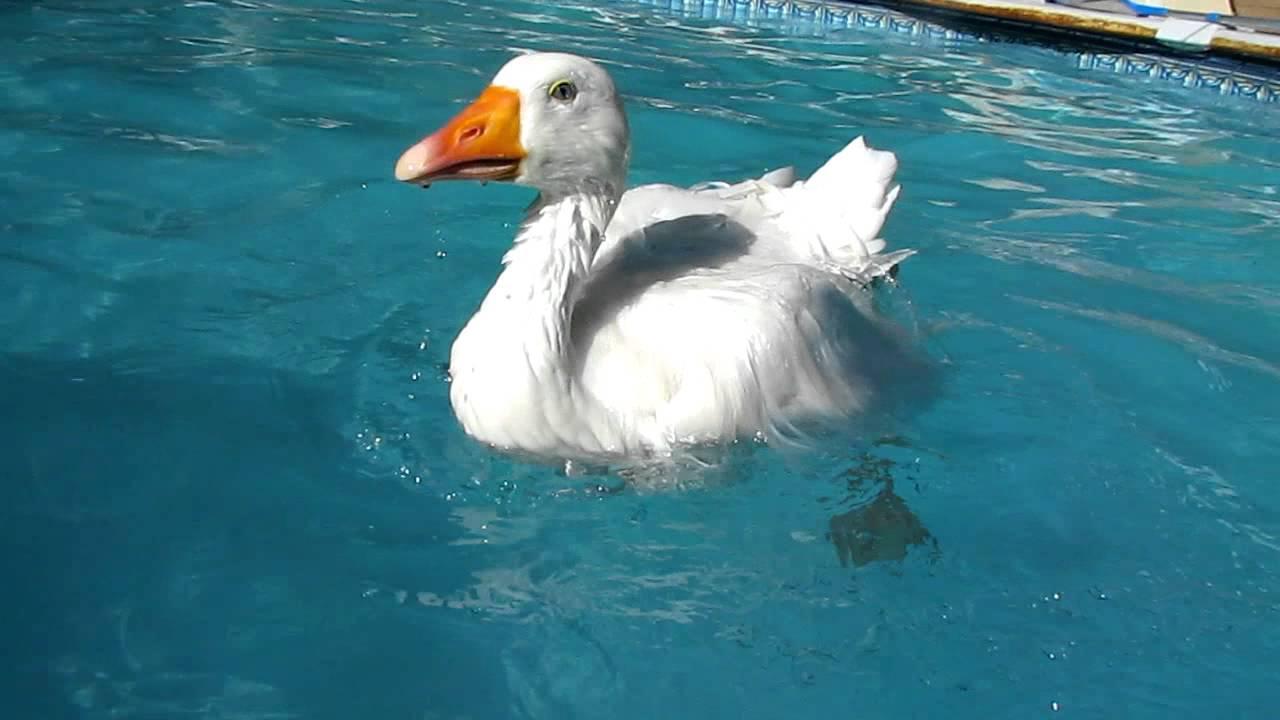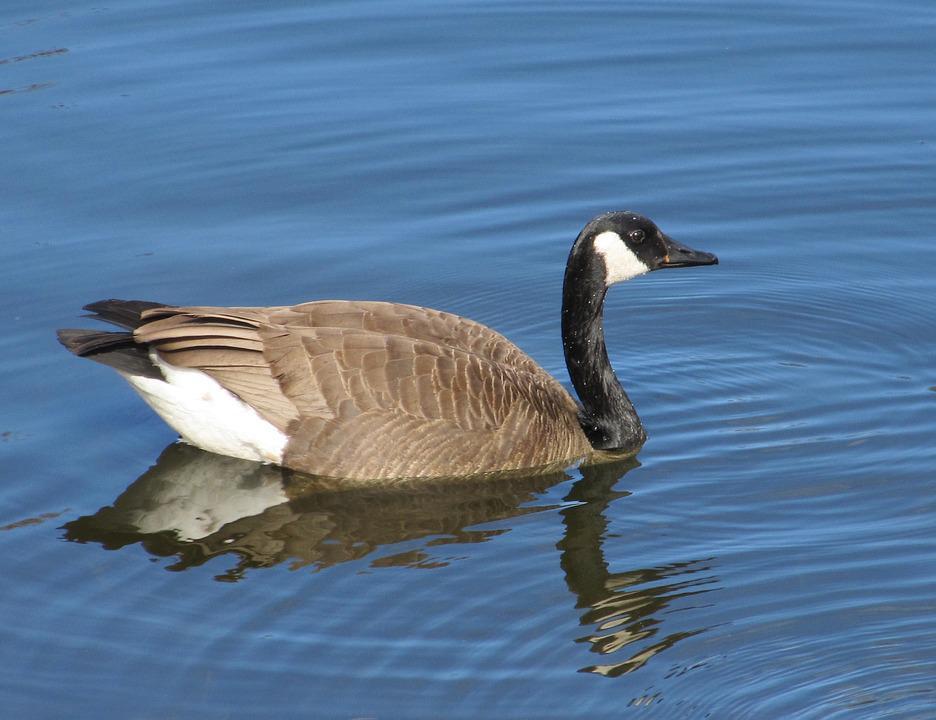The first image is the image on the left, the second image is the image on the right. Evaluate the accuracy of this statement regarding the images: "Each image shows exactly one bird floating on water, and at least one of the birds is a Canadian goose.". Is it true? Answer yes or no. Yes. The first image is the image on the left, the second image is the image on the right. Considering the images on both sides, is "The right image contains at least two ducks." valid? Answer yes or no. No. 